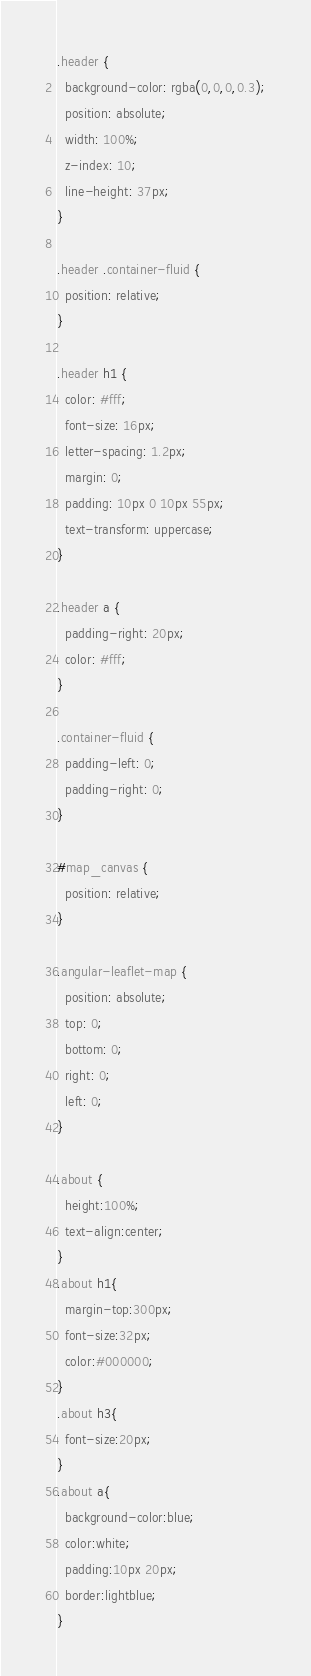Convert code to text. <code><loc_0><loc_0><loc_500><loc_500><_CSS_>.header {
  background-color: rgba(0,0,0,0.3);
  position: absolute;
  width: 100%;
  z-index: 10;
  line-height: 37px;
}

.header .container-fluid {
  position: relative;
}

.header h1 {
  color: #fff;
  font-size: 16px;
  letter-spacing: 1.2px;    
  margin: 0;
  padding: 10px 0 10px 55px;
  text-transform: uppercase;
}

.header a {
  padding-right: 20px;
  color: #fff;
}

.container-fluid {
  padding-left: 0;
  padding-right: 0;
}

#map_canvas {
  position: relative;
}

.angular-leaflet-map {
  position: absolute;
  top: 0;
  bottom: 0;
  right: 0;
  left: 0;
}

.about {
  height:100%;
  text-align:center;
}
.about h1{
  margin-top:300px;
  font-size:32px;
  color:#000000;
}
.about h3{
  font-size:20px;
}
.about a{
  background-color:blue;
  color:white;
  padding:10px 20px;
  border:lightblue;
}
</code> 